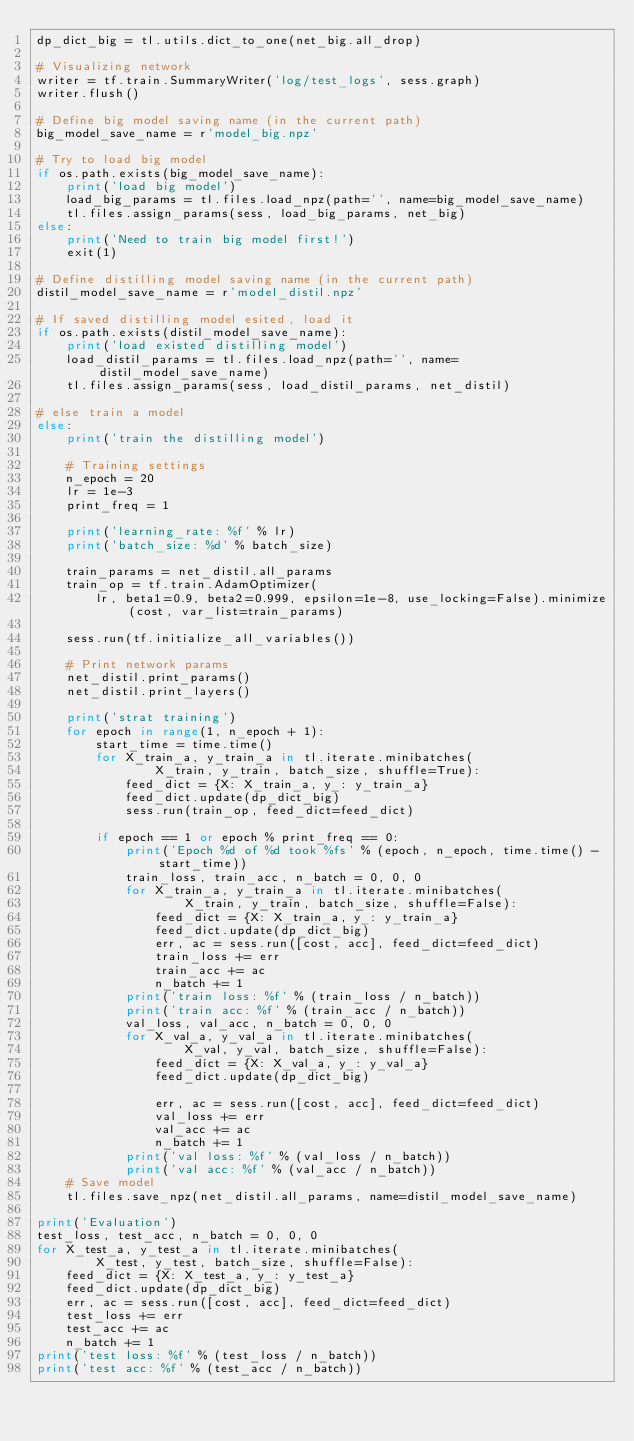Convert code to text. <code><loc_0><loc_0><loc_500><loc_500><_Python_>dp_dict_big = tl.utils.dict_to_one(net_big.all_drop)

# Visualizing network
writer = tf.train.SummaryWriter('log/test_logs', sess.graph)
writer.flush()

# Define big model saving name (in the current path)
big_model_save_name = r'model_big.npz'

# Try to load big model
if os.path.exists(big_model_save_name):
    print('load big model')
    load_big_params = tl.files.load_npz(path='', name=big_model_save_name)
    tl.files.assign_params(sess, load_big_params, net_big)
else:
    print('Need to train big model first!')
    exit(1)

# Define distilling model saving name (in the current path)
distil_model_save_name = r'model_distil.npz'

# If saved distilling model esited, load it
if os.path.exists(distil_model_save_name):
    print('load existed distilling model')
    load_distil_params = tl.files.load_npz(path='', name=distil_model_save_name)
    tl.files.assign_params(sess, load_distil_params, net_distil)

# else train a model
else:
    print('train the distilling model')

    # Training settings
    n_epoch = 20
    lr = 1e-3
    print_freq = 1

    print('learning_rate: %f' % lr)
    print('batch_size: %d' % batch_size)

    train_params = net_distil.all_params
    train_op = tf.train.AdamOptimizer(
        lr, beta1=0.9, beta2=0.999, epsilon=1e-8, use_locking=False).minimize(cost, var_list=train_params)

    sess.run(tf.initialize_all_variables())

    # Print network params
    net_distil.print_params()
    net_distil.print_layers()

    print('strat training')
    for epoch in range(1, n_epoch + 1):
        start_time = time.time()
        for X_train_a, y_train_a in tl.iterate.minibatches(
                X_train, y_train, batch_size, shuffle=True):
            feed_dict = {X: X_train_a, y_: y_train_a}
            feed_dict.update(dp_dict_big)
            sess.run(train_op, feed_dict=feed_dict)

        if epoch == 1 or epoch % print_freq == 0:
            print('Epoch %d of %d took %fs' % (epoch, n_epoch, time.time() - start_time))
            train_loss, train_acc, n_batch = 0, 0, 0
            for X_train_a, y_train_a in tl.iterate.minibatches(
                    X_train, y_train, batch_size, shuffle=False):
                feed_dict = {X: X_train_a, y_: y_train_a}
                feed_dict.update(dp_dict_big)
                err, ac = sess.run([cost, acc], feed_dict=feed_dict)
                train_loss += err
                train_acc += ac
                n_batch += 1
            print('train loss: %f' % (train_loss / n_batch))
            print('train acc: %f' % (train_acc / n_batch))
            val_loss, val_acc, n_batch = 0, 0, 0
            for X_val_a, y_val_a in tl.iterate.minibatches(
                    X_val, y_val, batch_size, shuffle=False):
                feed_dict = {X: X_val_a, y_: y_val_a}
                feed_dict.update(dp_dict_big)

                err, ac = sess.run([cost, acc], feed_dict=feed_dict)
                val_loss += err
                val_acc += ac
                n_batch += 1
            print('val loss: %f' % (val_loss / n_batch))
            print('val acc: %f' % (val_acc / n_batch))
    # Save model
    tl.files.save_npz(net_distil.all_params, name=distil_model_save_name)

print('Evaluation')
test_loss, test_acc, n_batch = 0, 0, 0
for X_test_a, y_test_a in tl.iterate.minibatches(
        X_test, y_test, batch_size, shuffle=False):
    feed_dict = {X: X_test_a, y_: y_test_a}
    feed_dict.update(dp_dict_big)
    err, ac = sess.run([cost, acc], feed_dict=feed_dict)
    test_loss += err
    test_acc += ac
    n_batch += 1
print('test loss: %f' % (test_loss / n_batch))
print('test acc: %f' % (test_acc / n_batch))
</code> 